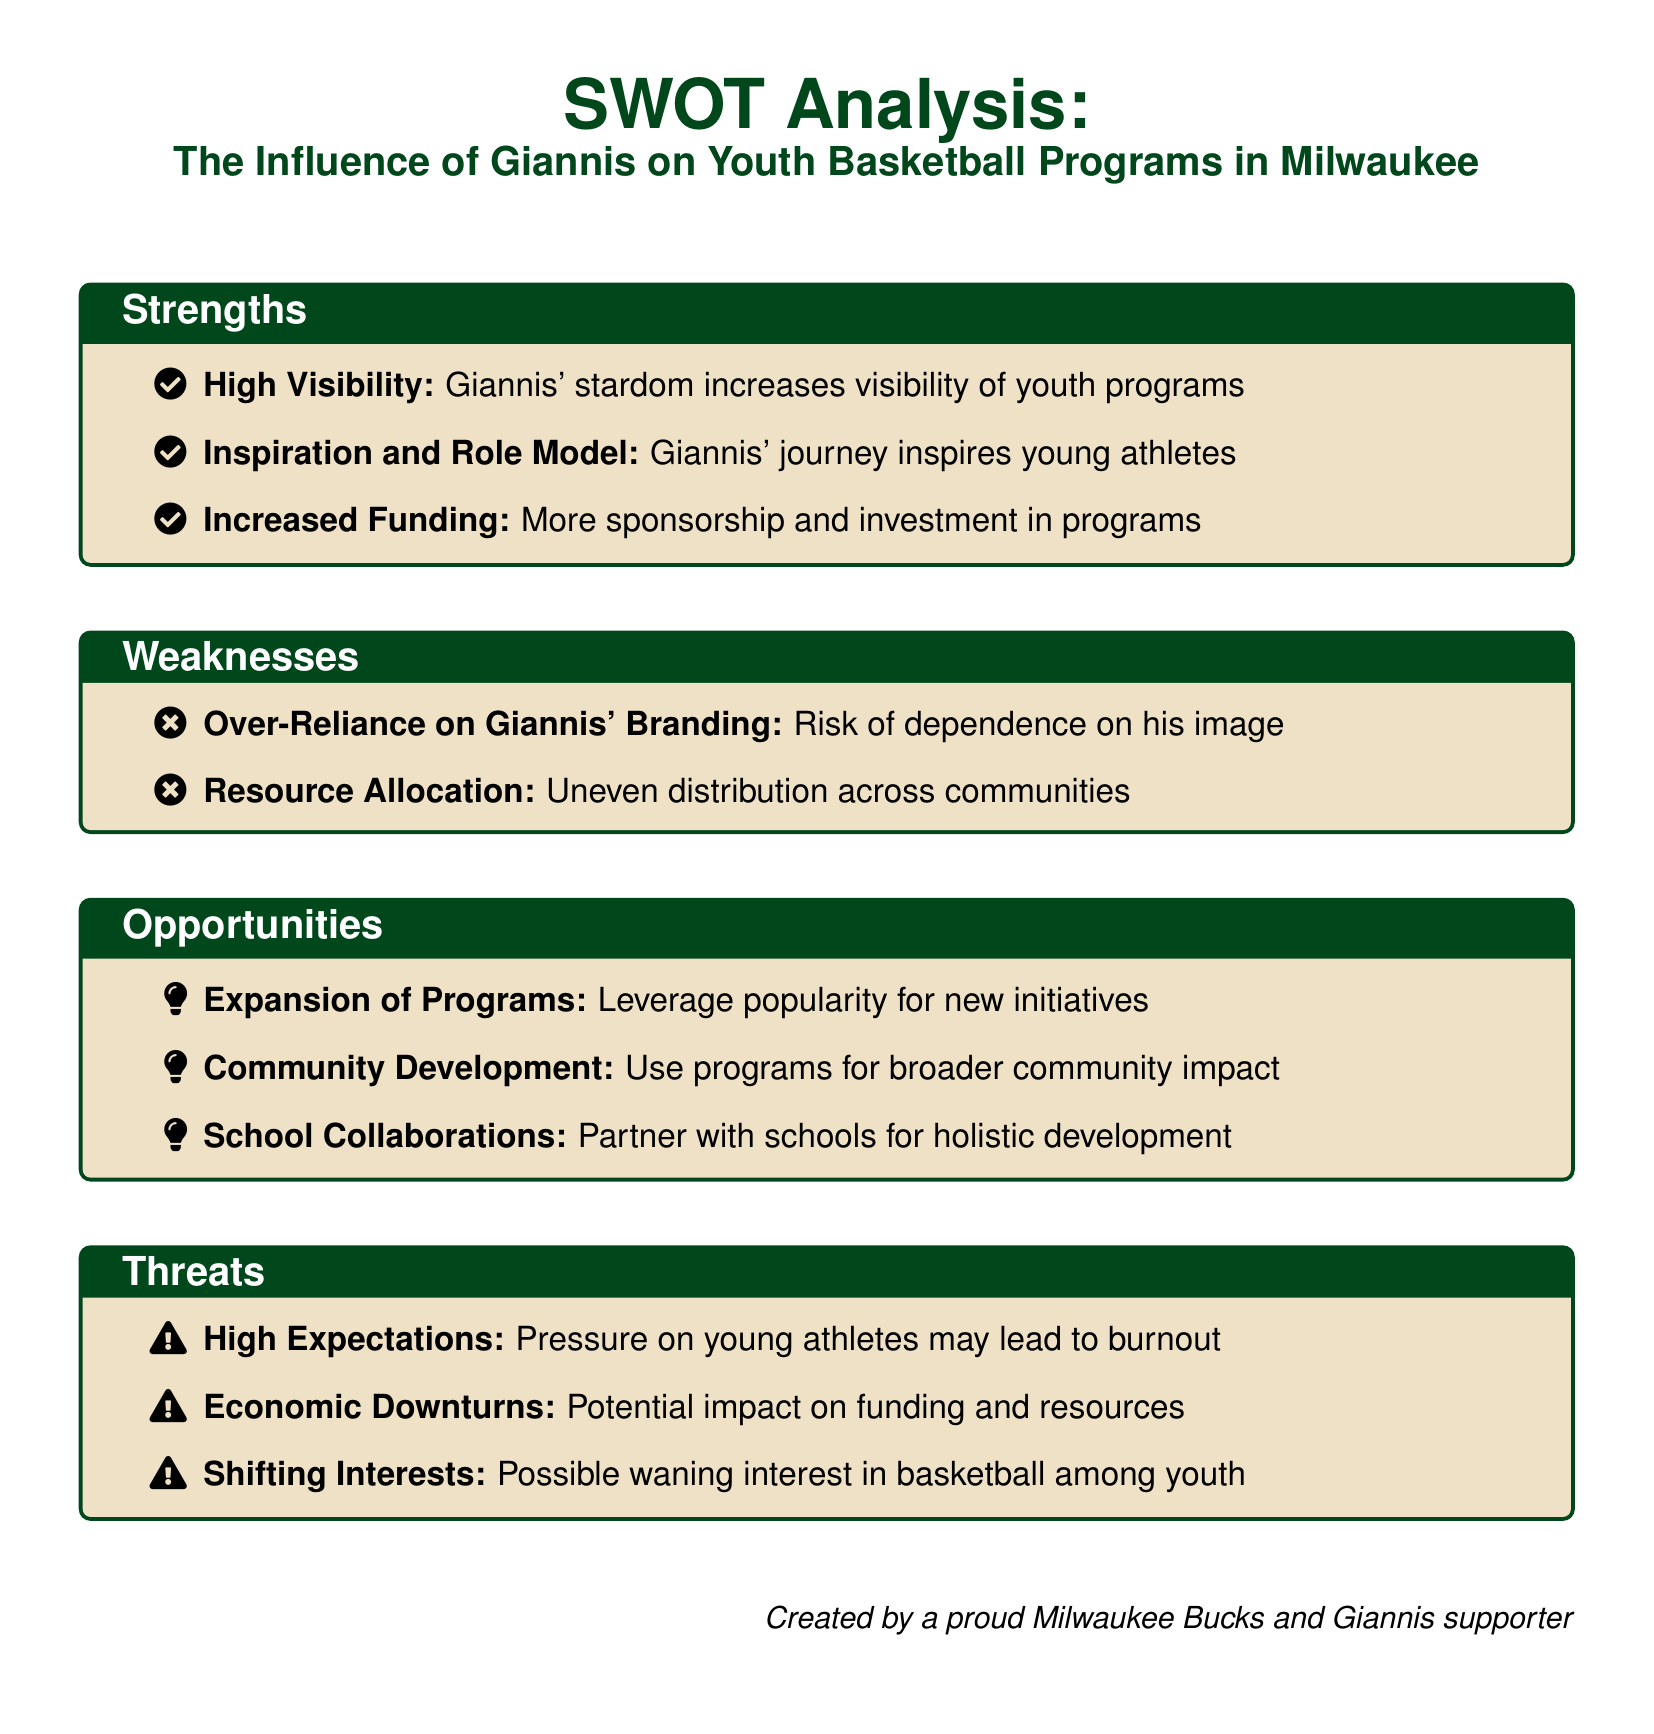What is the title of the analysis? The title is the main heading of the document, which is clearly stated.
Answer: The Influence of Giannis on Youth Basketball Programs in Milwaukee What color is used for the boxes in the SWOT analysis? The document specifies the color used for the boxes with clear labels.
Answer: Buckscream How many strengths are listed in the analysis? The strengths section enumerates the points included under strengths.
Answer: Three What is one opportunity mentioned in the SWOT analysis? The opportunities section highlights potential areas for growth or development.
Answer: Expansion of Programs What weakness involves dependence on Giannis? The document lists weaknesses that highlight issues related to Giannis' influence.
Answer: Over-Reliance on Giannis' Branding What threat pertains to young athletes' performance? The document mentions threats associated with pressure on young athletes.
Answer: High Expectations How does the analysis suggest improving community impact? The opportunities section indicates ways to enhance community engagement.
Answer: Community Development What is a potential economic threat to youth basketball programs? The threats section discusses factors that could negatively impact funding.
Answer: Economic Downturns What aspect does the analysis suggest collaborating with schools on? The document proposes a specific area for partnership to enhance youth programs.
Answer: Holistic development 